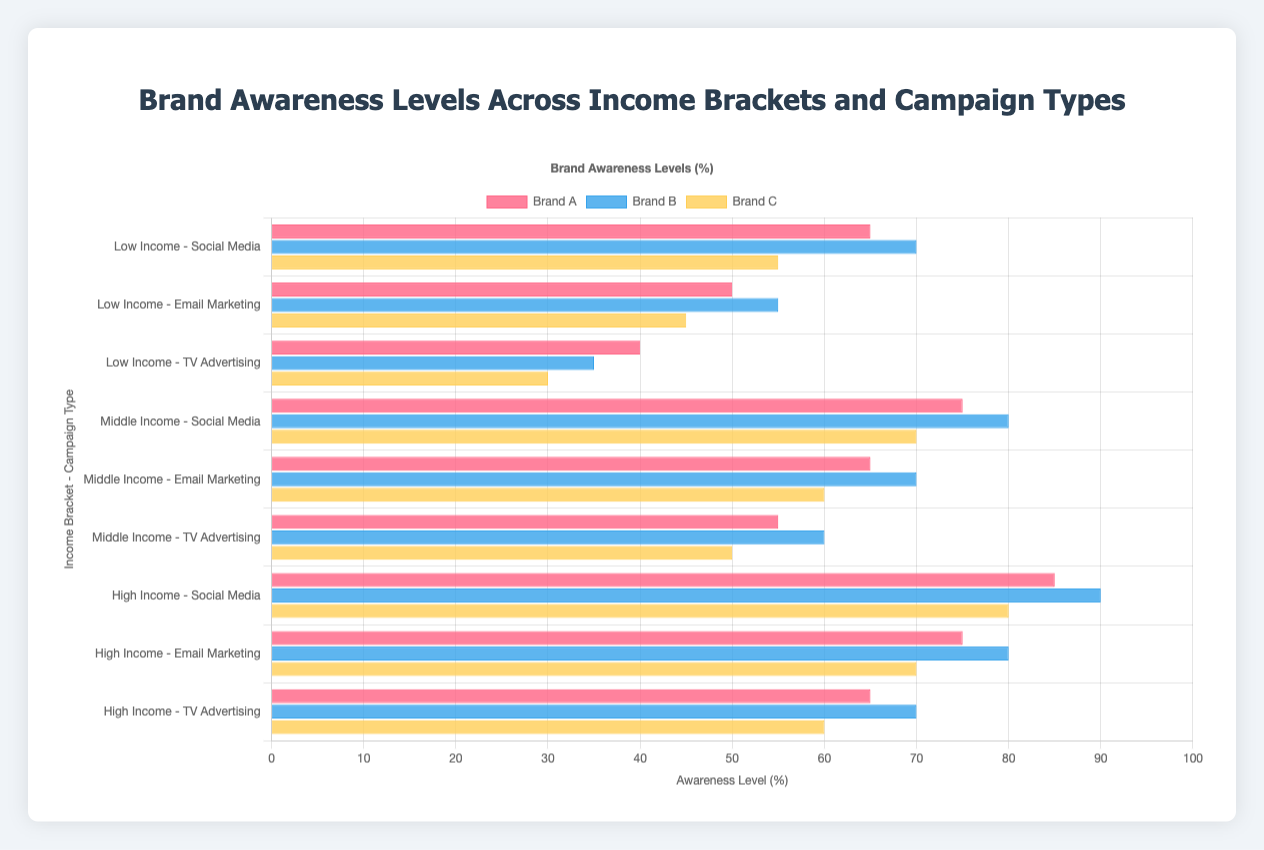What is the awareness level of Brand C in the high-income bracket for TV advertising campaigns? To find this, look at the row labeled "High Income - TV Advertising" and the value associated with Brand C. The chart shows that this value is 60.
Answer: 60 Which brand has the highest awareness level in the middle-income bracket for email marketing campaigns? To determine the answer, look at the row labeled "Middle Income - Email Marketing" and compare the values for Brand A, Brand B, and Brand C. Brand B has the highest value at 70.
Answer: Brand B What is the difference in awareness levels between Brand A in the high-income bracket for social media campaigns and Brand C in the low-income bracket for TV advertising campaigns? Look at Brand A's value in the "High Income - Social Media" row (85) and subtract the value for Brand C in the "Low Income - TV Advertising" row (30). The result is 85 - 30 = 55.
Answer: 55 Comparing the awareness levels for email marketing campaigns, which income bracket shows the highest awareness level for Brand B? Look at all rows labeled "Email Marketing" and compare the Brand B values. The values are 55 (Low Income), 70 (Middle Income), and 80 (High Income). The highest awareness level is in the High Income bracket at 80.
Answer: High Income What is the average awareness level of Brand A across all TV advertising campaigns? Add the values for Brand A in all TV Advertising rows: 40 (Low Income), 55 (Middle Income), and 65 (High Income), then divide by the number of rows (3). The sum is 40 + 55 + 65 = 160, and the average is 160 / 3 ≈ 53.33.
Answer: 53.33 Which campaign type and income bracket combination shows the lowest awareness level for Brand B? Identify the minimum value for Brand B across all rows. The lowest values are 35, and it is found in the "Low Income - TV Advertising" row.
Answer: Low Income - TV Advertising How much greater is the awareness level of Brand A in middle-income social media campaigns compared to low-income email marketing campaigns? Compare Brand A's values for "Middle Income - Social Media" (75) and "Low Income - Email Marketing" (50). The difference is 75 - 50 = 25.
Answer: 25 Which brand consistently shows the lowest awareness level across all campaign types within the low-income bracket? Within the "Low Income" rows, compare the values for Brand A, Brand B, and Brand C in each campaign type. Brand C has the lowest values of 55, 45, and 30 consistently across all campaign types.
Answer: Brand C On average, how much higher is the awareness level of Brand B compared to Brand A in TV advertising campaigns? First, calculate the differences for each income bracket: (35 - 40), (60 - 55), and (70 - 65), which are -5, 5, and 5. Then, find the average difference: (-5 + 5 + 5) / 3 = 5 / 3 ≈ 1.67.
Answer: 1.67 